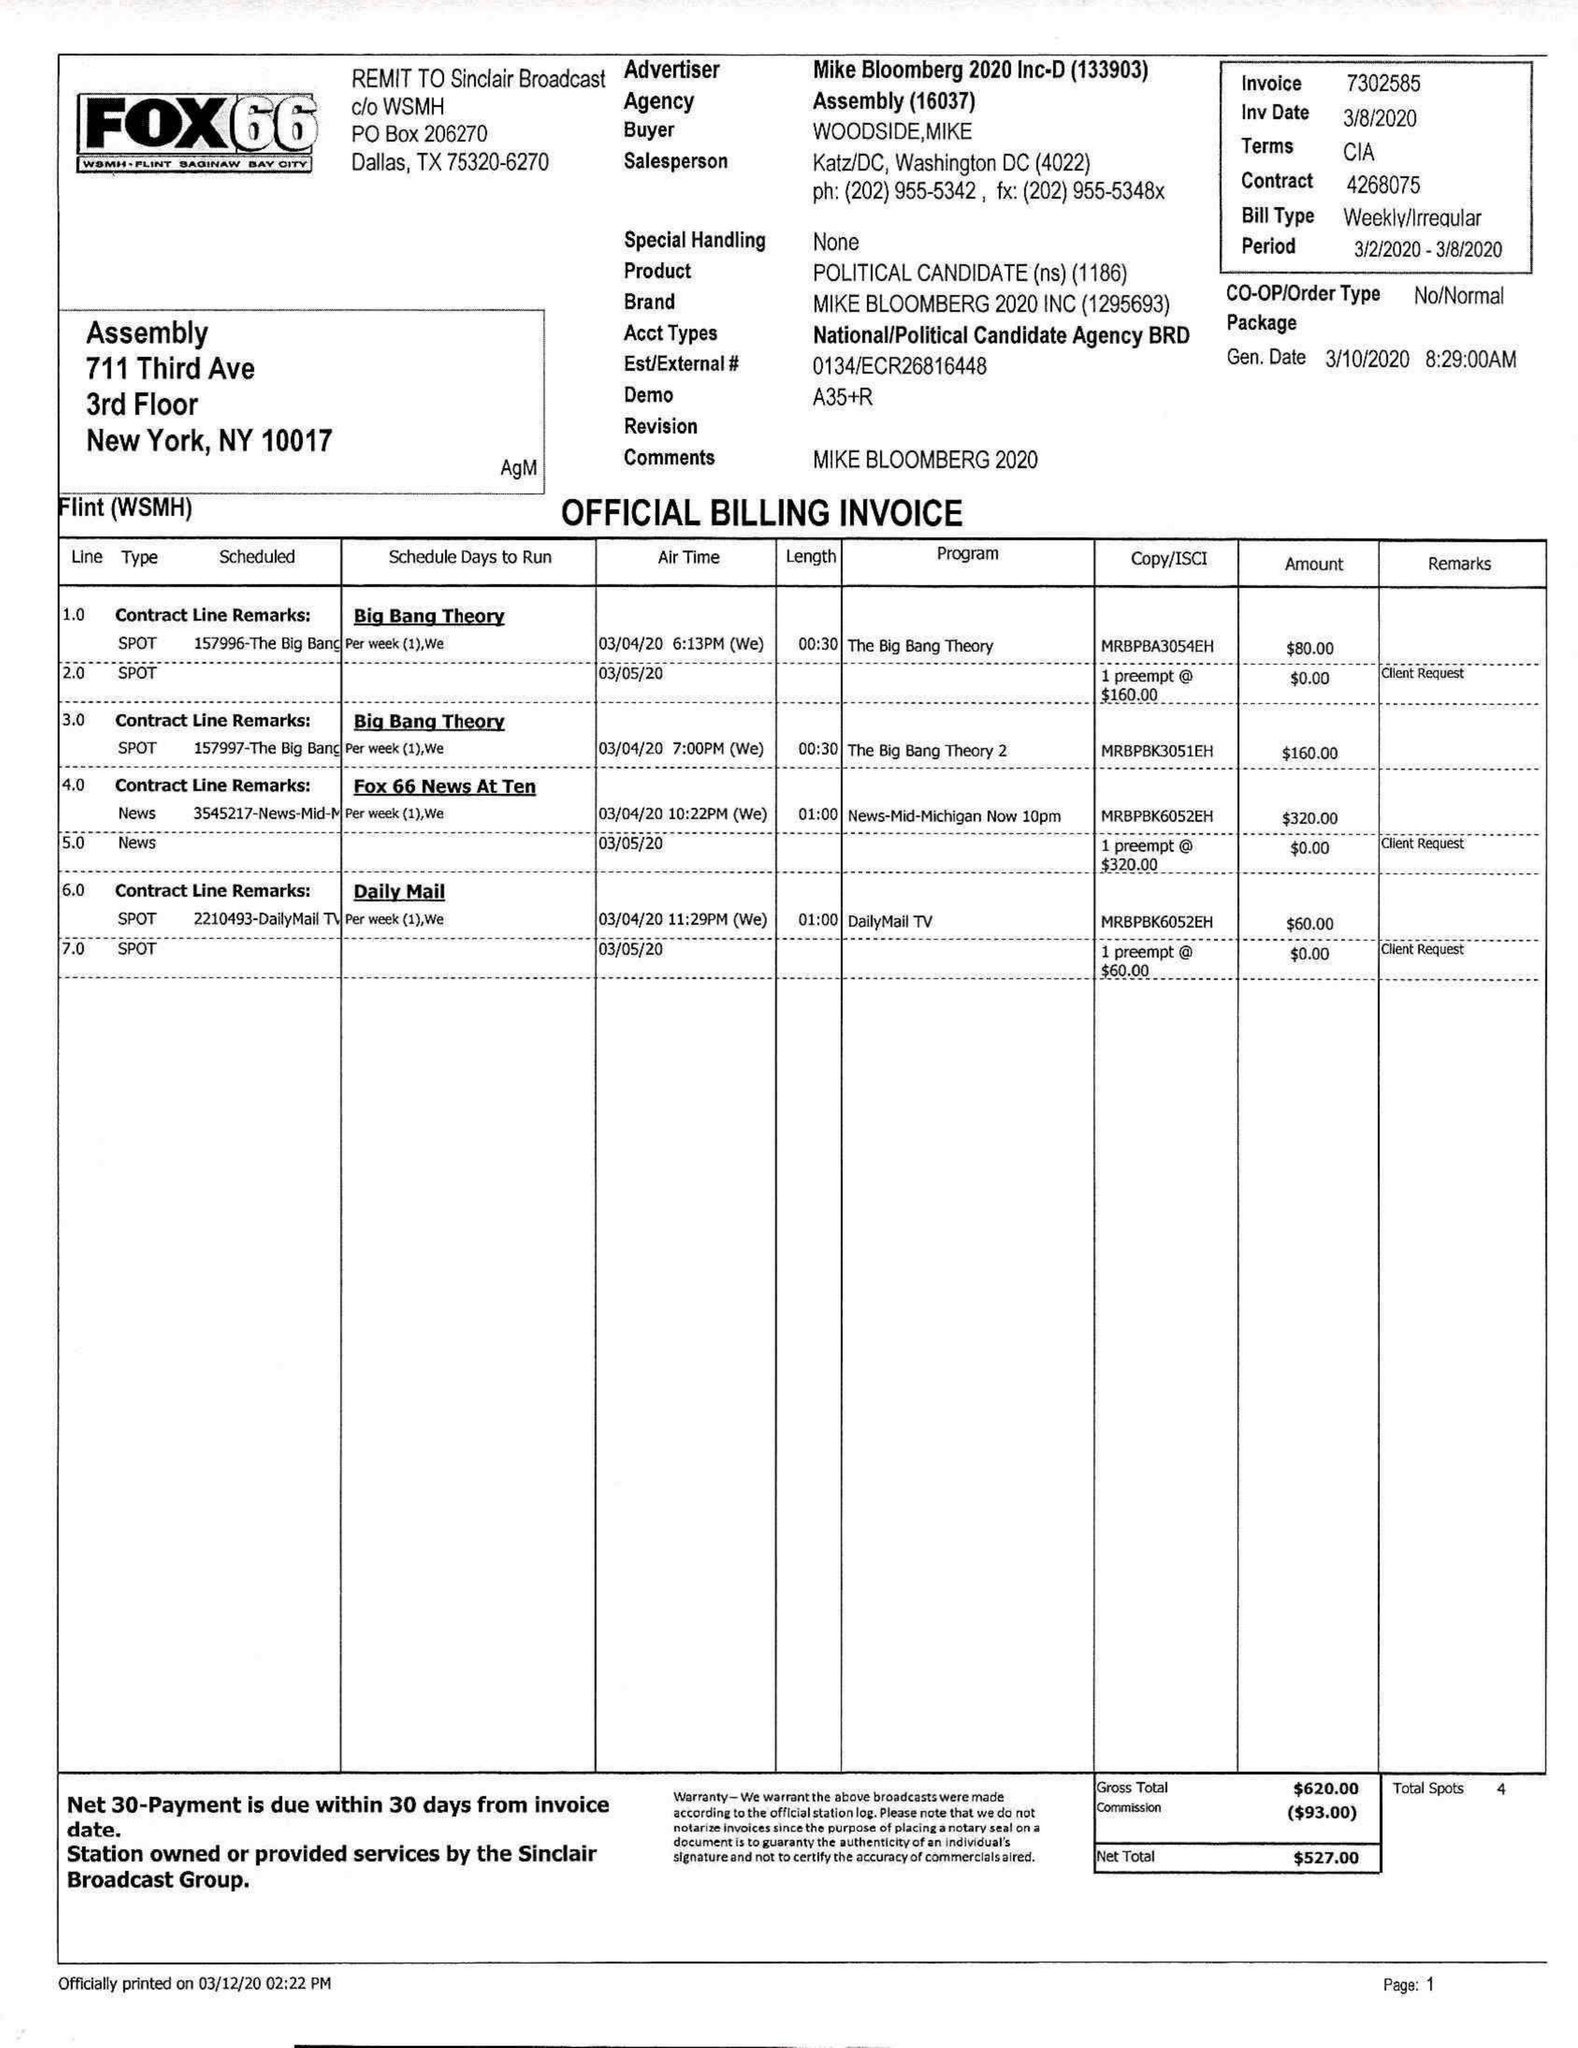What is the value for the flight_to?
Answer the question using a single word or phrase. 03/08/20 